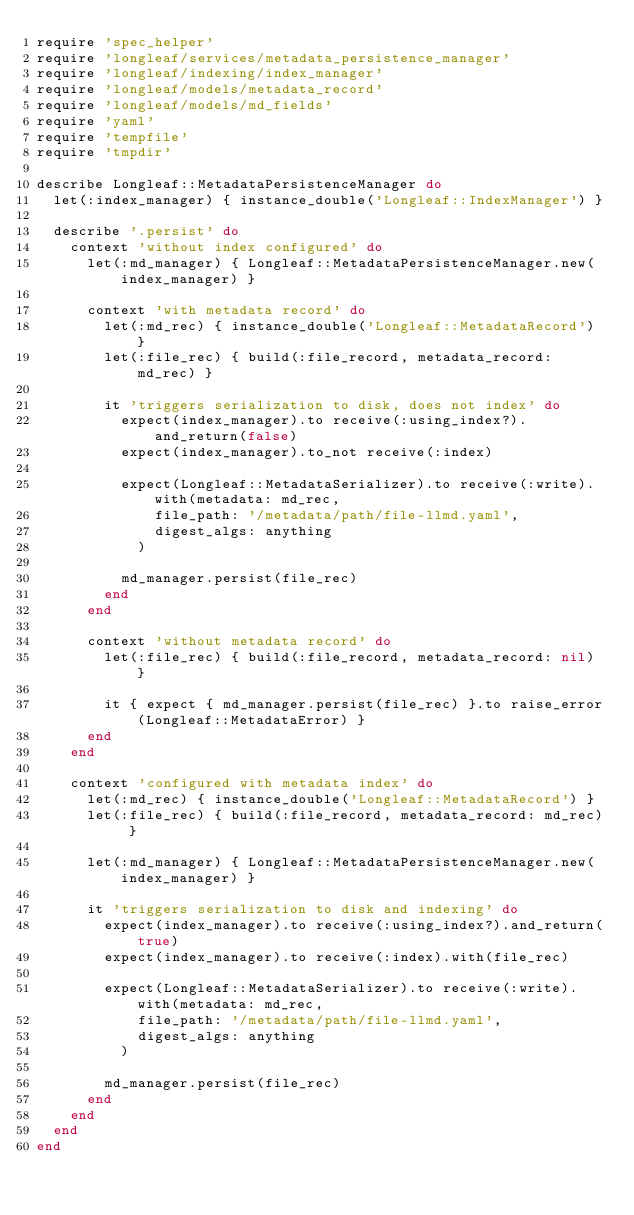Convert code to text. <code><loc_0><loc_0><loc_500><loc_500><_Ruby_>require 'spec_helper'
require 'longleaf/services/metadata_persistence_manager'
require 'longleaf/indexing/index_manager'
require 'longleaf/models/metadata_record'
require 'longleaf/models/md_fields'
require 'yaml'
require 'tempfile'
require 'tmpdir'

describe Longleaf::MetadataPersistenceManager do
  let(:index_manager) { instance_double('Longleaf::IndexManager') }

  describe '.persist' do
    context 'without index configured' do
      let(:md_manager) { Longleaf::MetadataPersistenceManager.new(index_manager) }

      context 'with metadata record' do
        let(:md_rec) { instance_double('Longleaf::MetadataRecord') }
        let(:file_rec) { build(:file_record, metadata_record: md_rec) }

        it 'triggers serialization to disk, does not index' do
          expect(index_manager).to receive(:using_index?).and_return(false)
          expect(index_manager).to_not receive(:index)

          expect(Longleaf::MetadataSerializer).to receive(:write).with(metadata: md_rec,
              file_path: '/metadata/path/file-llmd.yaml',
              digest_algs: anything
            )

          md_manager.persist(file_rec)
        end
      end

      context 'without metadata record' do
        let(:file_rec) { build(:file_record, metadata_record: nil) }

        it { expect { md_manager.persist(file_rec) }.to raise_error(Longleaf::MetadataError) }
      end
    end

    context 'configured with metadata index' do
      let(:md_rec) { instance_double('Longleaf::MetadataRecord') }
      let(:file_rec) { build(:file_record, metadata_record: md_rec) }

      let(:md_manager) { Longleaf::MetadataPersistenceManager.new(index_manager) }

      it 'triggers serialization to disk and indexing' do
        expect(index_manager).to receive(:using_index?).and_return(true)
        expect(index_manager).to receive(:index).with(file_rec)

        expect(Longleaf::MetadataSerializer).to receive(:write).with(metadata: md_rec,
            file_path: '/metadata/path/file-llmd.yaml',
            digest_algs: anything
          )

        md_manager.persist(file_rec)
      end
    end
  end
end
</code> 